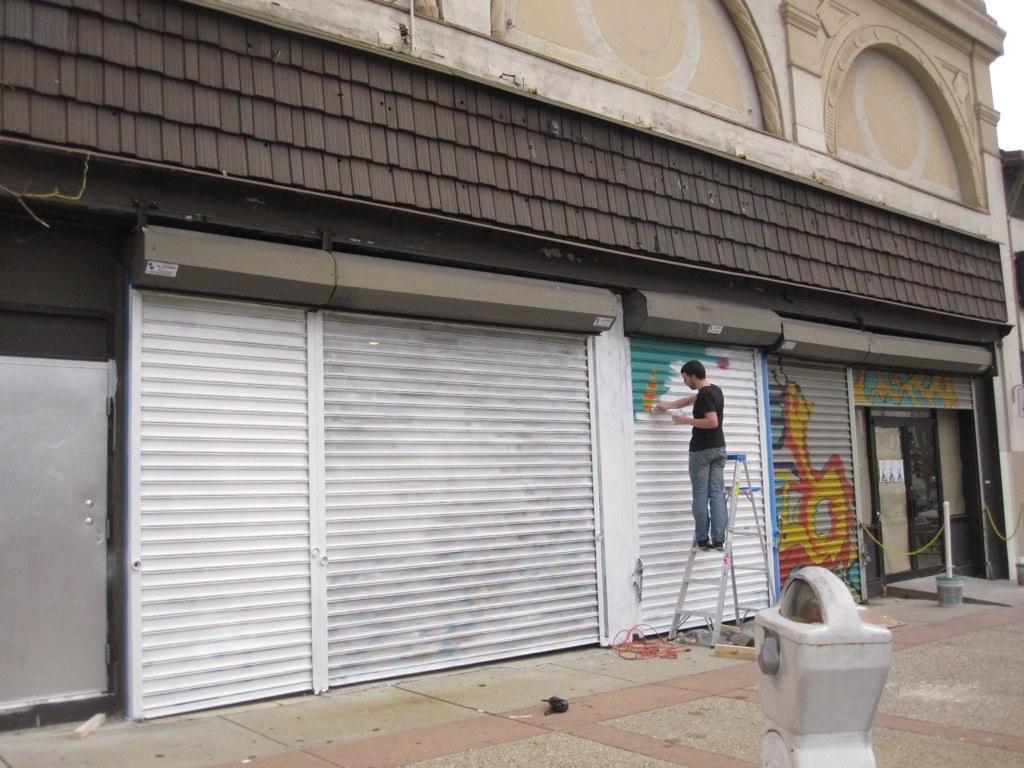Could you give a brief overview of what you see in this image? In this picture we can see a man is standing on the ladder and he is holding an object. At the bottom of the image, there is an object. On the right side of the image, there is a bucket and a pole. In front of the man, there is a building with the rolling shutters. In the bottom right corner of the image, there is the sky. 